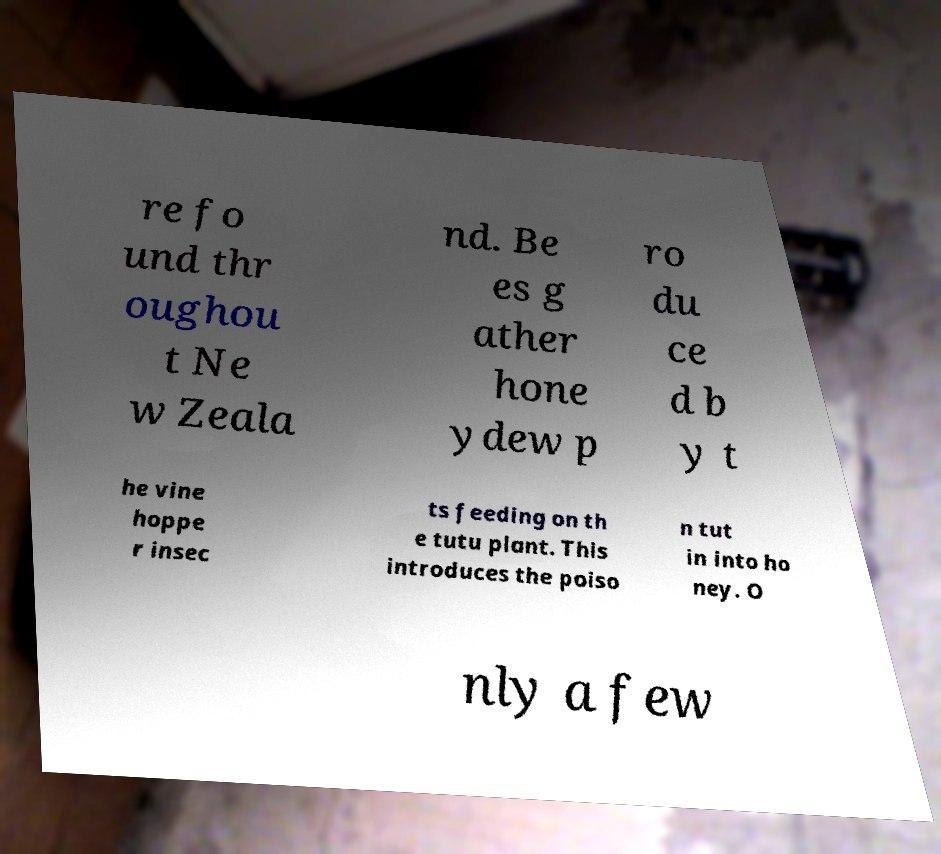Could you extract and type out the text from this image? re fo und thr oughou t Ne w Zeala nd. Be es g ather hone ydew p ro du ce d b y t he vine hoppe r insec ts feeding on th e tutu plant. This introduces the poiso n tut in into ho ney. O nly a few 